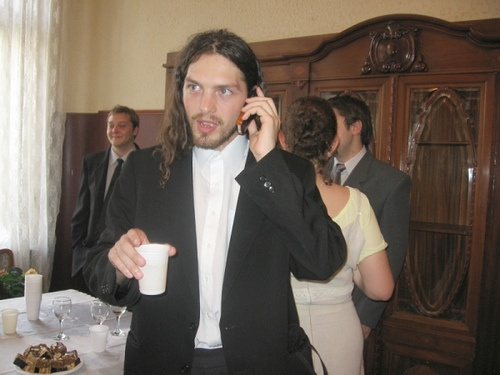Describe the objects in this image and their specific colors. I can see people in white, black, lightgray, gray, and tan tones, people in white, darkgray, black, and tan tones, dining table in white, darkgray, lightgray, and gray tones, people in white, black, and gray tones, and people in white, black, gray, and brown tones in this image. 